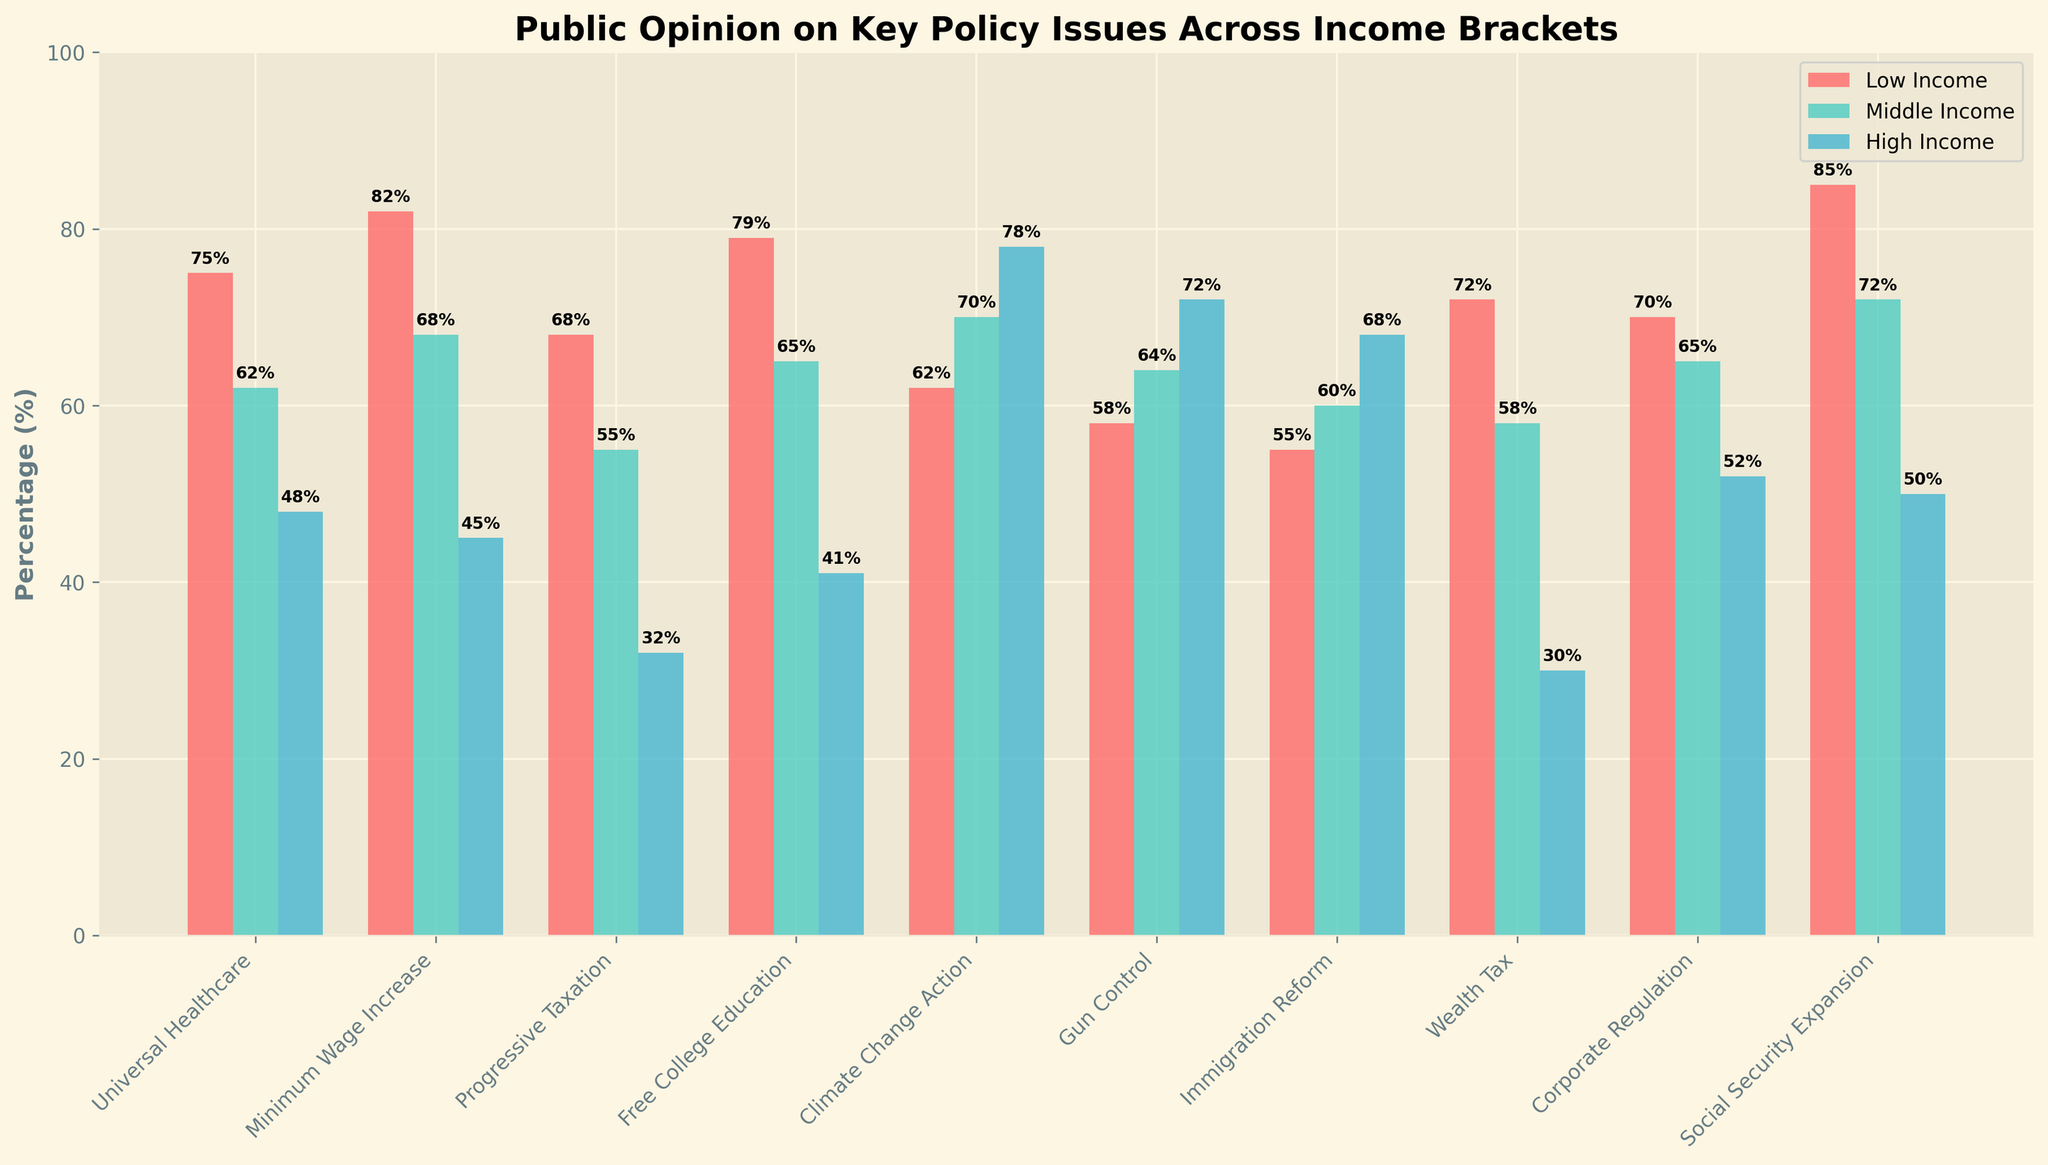What's the percentage difference between high-income support for "Gun Control" and "Wealth Tax"? Look at the "Gun Control" bar for high-income (72%) and "Wealth Tax" bar for high-income (30%). Calculate the percentage difference as 72% - 30% = 42%.
Answer: 42% Which income bracket supports "Minimum Wage Increase" the most? Compare the heights of the bars for "Minimum Wage Increase" across all income brackets. The highest bar is for the low-income bracket at 82%.
Answer: Low Income What is the average support for "Corporate Regulation" across all income brackets? Sum the support percentages from all income brackets for "Corporate Regulation" (70% + 65% + 52%) and divide by the number of income brackets (3) to get (70 + 65 + 52) / 3 = 62.33%.
Answer: 62.33% Which policy issue has the highest overall support from the low-income bracket? Identify the tallest bar in the low-income bracket. The tallest bar is for "Social Security Expansion," which is at 85%.
Answer: Social Security Expansion How much more do low-income individuals support "Free College Education" compared to high-income individuals? Check the bars for "Free College Education" in low-income (79%) and high-income (41%). Calculate the difference as 79% - 41% = 38%.
Answer: 38% What's the trend in support across income brackets for "Climate Change Action"? Observe the bars for "Climate Change Action" across the brackets: low-income (62%), middle-income (70%), high-income (78%). Notice that the support increases as income increases.
Answer: Increasing How does middle-income support for "Progressive Taxation" compare to high-income support for "Universal Healthcare"? Look at the bars for middle-income "Progressive Taxation" (55%) and high-income "Universal Healthcare" (48%). Middle-income support for "Progressive Taxation" is higher (55% > 48%).
Answer: Higher Which income bracket shows the least support for "Minimum Wage Increase"? Identify the shortest bar for "Minimum Wage Increase". The shortest bar belongs to the high-income bracket at 45%.
Answer: High Income Which policy issue has the closest support percentages between middle-income and high-income brackets? Compare the differences in bar heights between middle-income and high-income for each policy issue. "Gun Control" has the closest percentages: middle-income (64%) and high-income (72%), with a difference of 8%.
Answer: Gun Control What is the sum of support percentages for "Universal Healthcare" across all income brackets? Add the support percentages for "Universal Healthcare" from low-income (75%), middle-income (62%), and high-income (48%): 75 + 62 + 48 = 185%.
Answer: 185% 